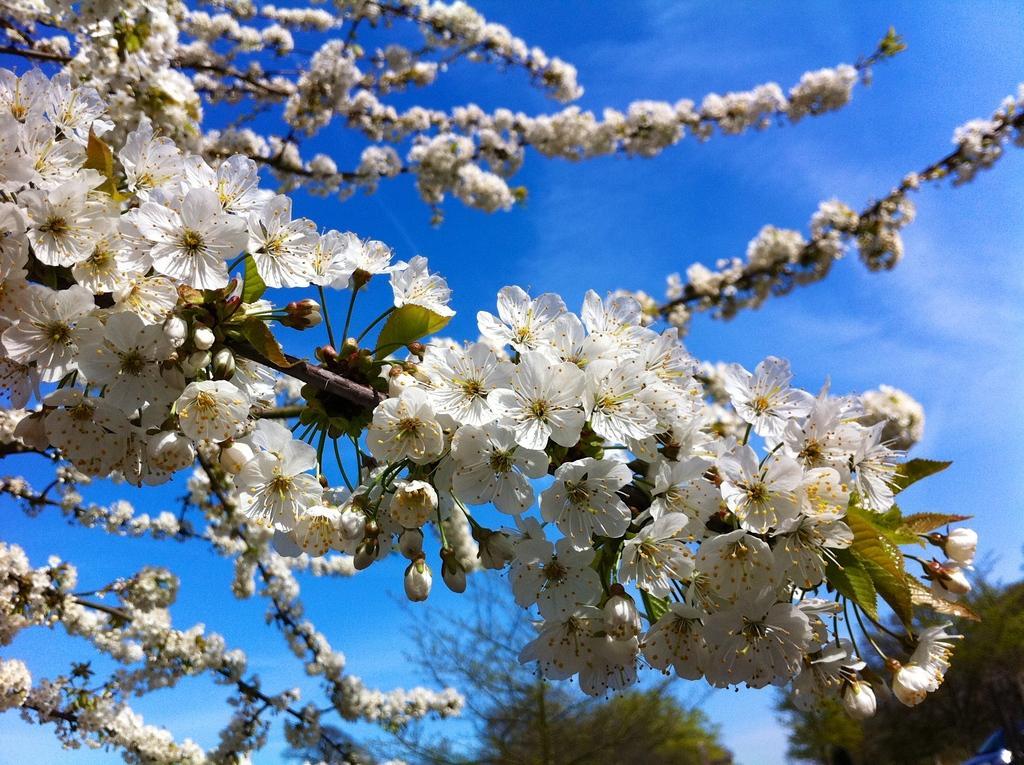In one or two sentences, can you explain what this image depicts? In this image we can see flowers and buds to the stems, trees and sky with clouds. 